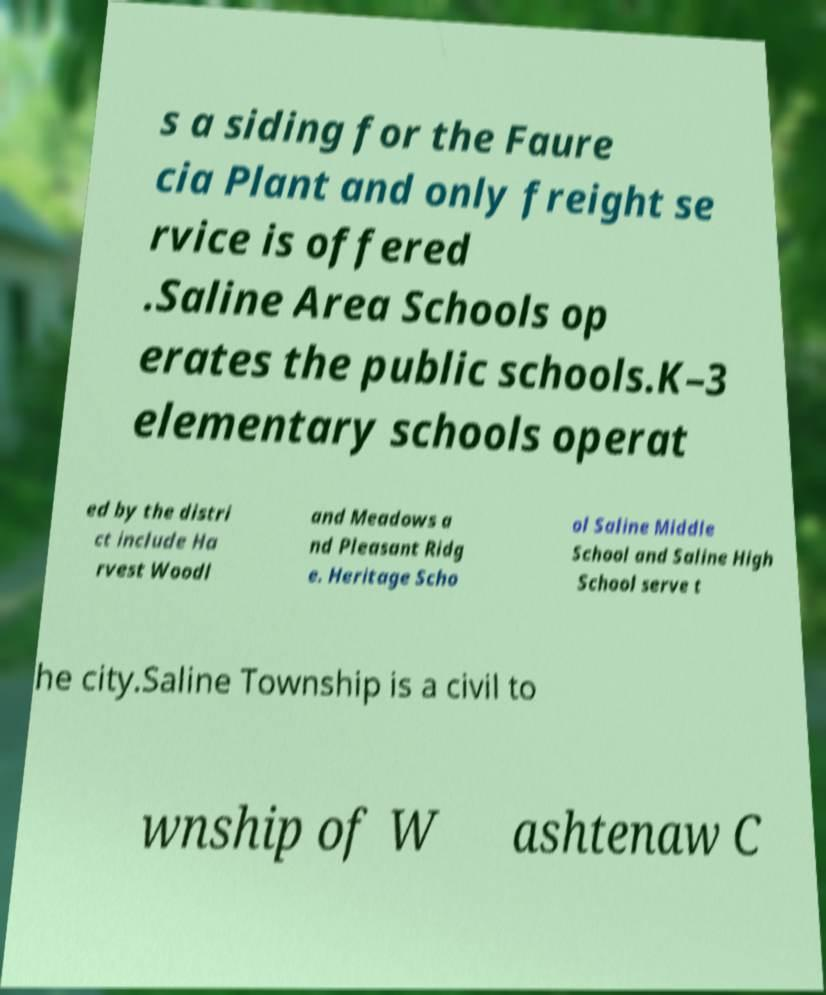Could you assist in decoding the text presented in this image and type it out clearly? s a siding for the Faure cia Plant and only freight se rvice is offered .Saline Area Schools op erates the public schools.K–3 elementary schools operat ed by the distri ct include Ha rvest Woodl and Meadows a nd Pleasant Ridg e. Heritage Scho ol Saline Middle School and Saline High School serve t he city.Saline Township is a civil to wnship of W ashtenaw C 